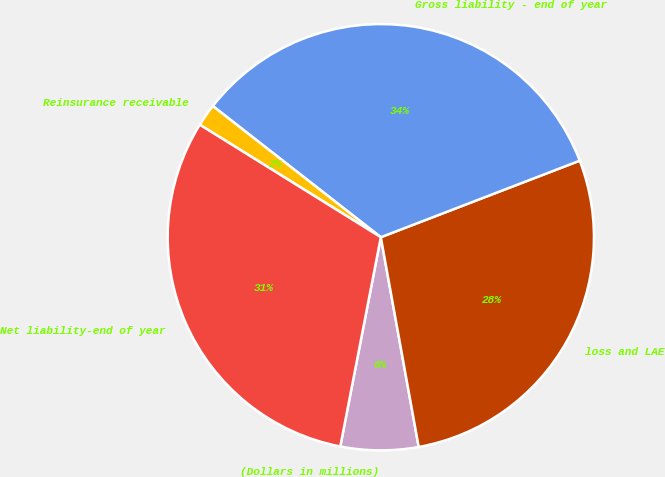Convert chart. <chart><loc_0><loc_0><loc_500><loc_500><pie_chart><fcel>(Dollars in millions)<fcel>loss and LAE<fcel>Gross liability - end of year<fcel>Reinsurance receivable<fcel>Net liability-end of year<nl><fcel>5.89%<fcel>28.0%<fcel>33.6%<fcel>1.7%<fcel>30.8%<nl></chart> 